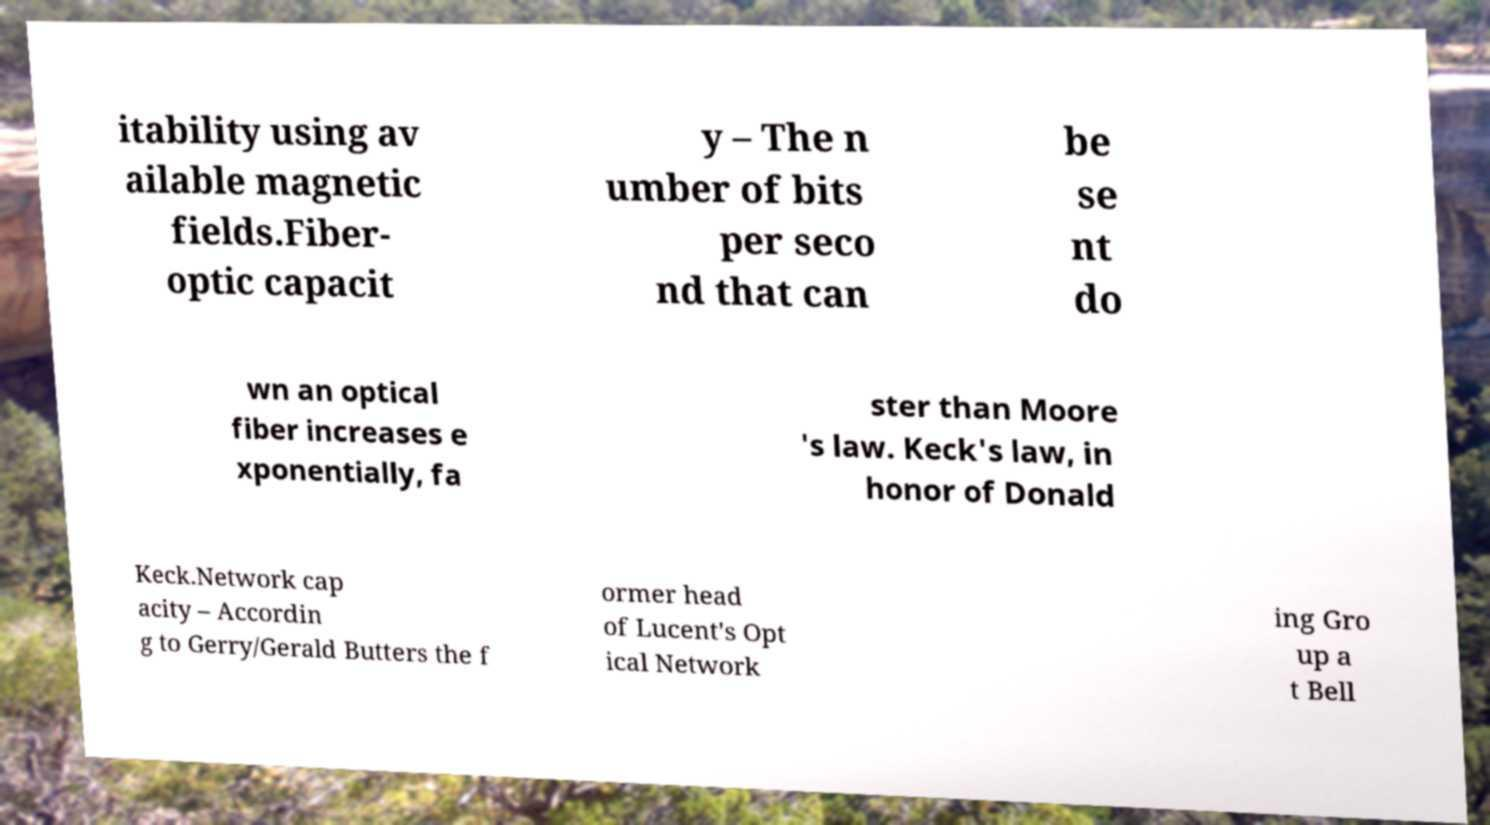I need the written content from this picture converted into text. Can you do that? itability using av ailable magnetic fields.Fiber- optic capacit y – The n umber of bits per seco nd that can be se nt do wn an optical fiber increases e xponentially, fa ster than Moore 's law. Keck's law, in honor of Donald Keck.Network cap acity – Accordin g to Gerry/Gerald Butters the f ormer head of Lucent's Opt ical Network ing Gro up a t Bell 